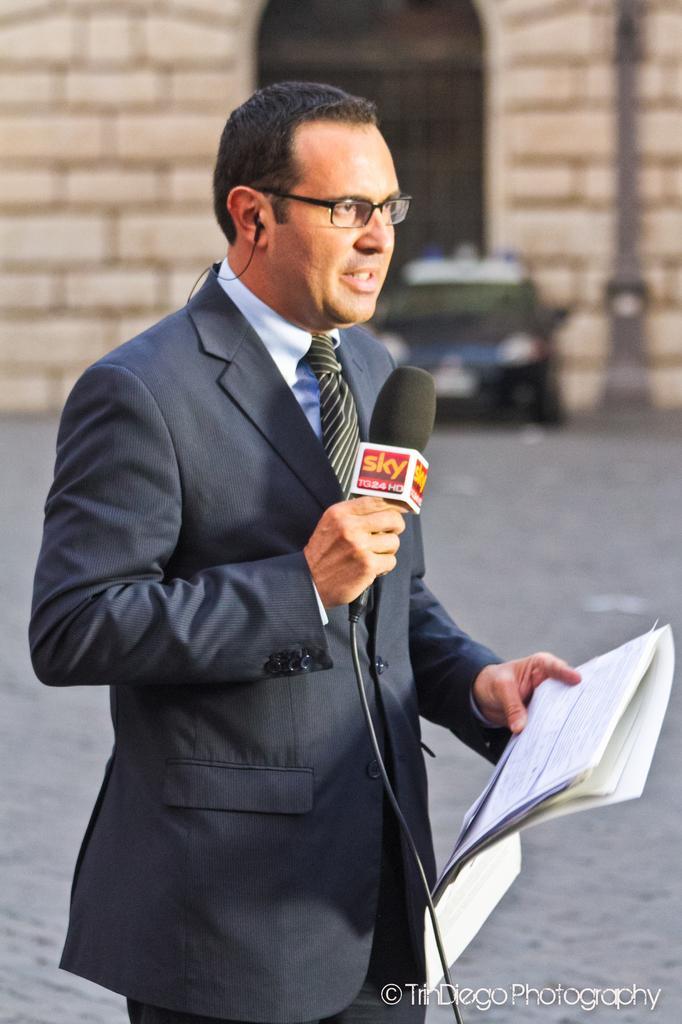Can you describe this image briefly? In this image there is a man who is holding some papers in one hand and holding a microphone in another hand and at the back ground there is a car , a building, a door and a pole. 